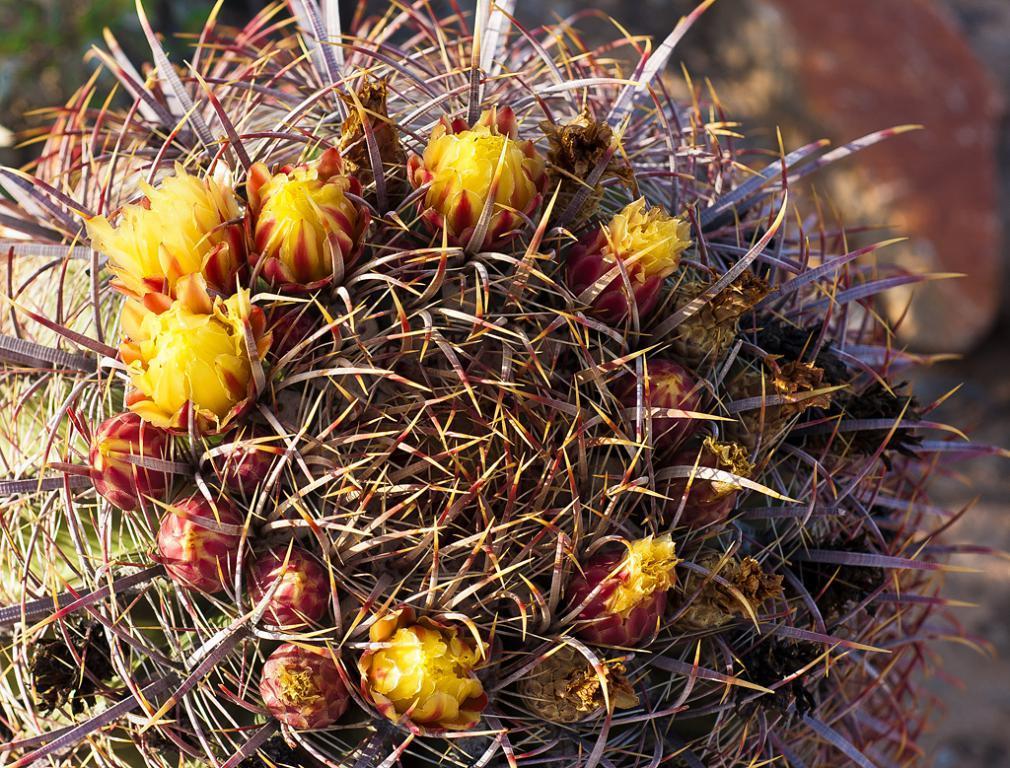Please provide a concise description of this image. This image is taken outdoors. In this image there is a cactus plant. 